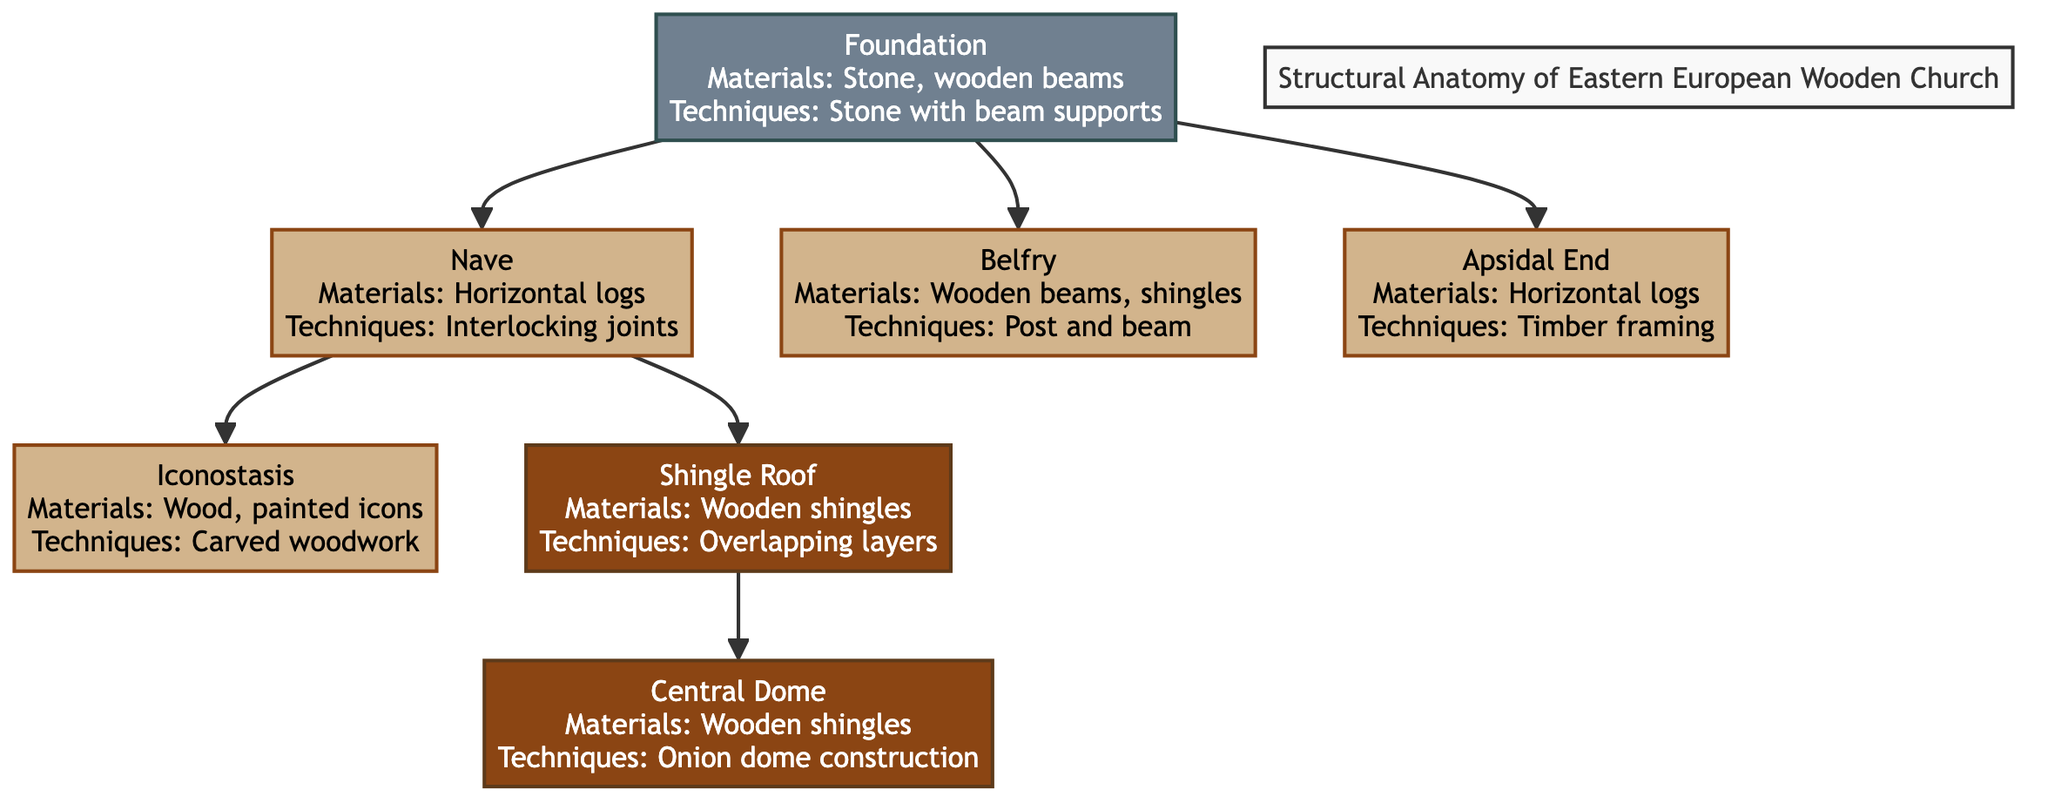What is the material used for the central dome? The diagram clearly states that the central dome is made of wooden shingles. This is found in the label next to the "Central Dome" node.
Answer: Wooden shingles How many types of roofs are indicated in the diagram? The diagram shows two types of roofs: the "Shingle Roof" and the "Central Dome." By counting the distinct roof-related nodes, we find a total of two.
Answer: 2 What technique is used in constructing the nave? The nave node indicates that the technique used is interlocking joints according to the label next to it. Therefore, this is the answer.
Answer: Interlocking joints Which material is associated with the belfry? The belfry node in the diagram notes that it is made from wooden beams and shingles, as described in the corresponding label.
Answer: Wooden beams, shingles What connects the foundation to the nave? The diagram shows a direct edge connecting the foundation node to the nave node, indicating they are structurally linked.
Answer: Nave What is the primary construction technique used for the iconostasis? The label for the iconostasis notes that it is crafted using carved woodwork, thus indicating this as the primary technique employed.
Answer: Carved woodwork How many components are highlighted in the foundation? The diagram contains one node that explicitly refers to the foundation, which is connected to the nave, belfry, and apsidal end, confirming there is only one main foundation component shown.
Answer: 1 Which part of the church's structure is made using timber framing? The diagram identifies the apsidal end as using timber framing, according to the information provided in its label.
Answer: Timber framing What technique is used for the shingle roof? The diagram describes that the technique for the shingle roof involves overlapping layers, as mentioned in the shingle roof's node label.
Answer: Overlapping layers 